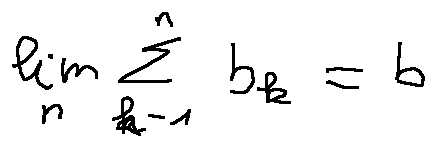Convert formula to latex. <formula><loc_0><loc_0><loc_500><loc_500>\lim \lim i t s _ { n } \sum \lim i t s _ { k = 1 } ^ { n } b _ { k } = b</formula> 